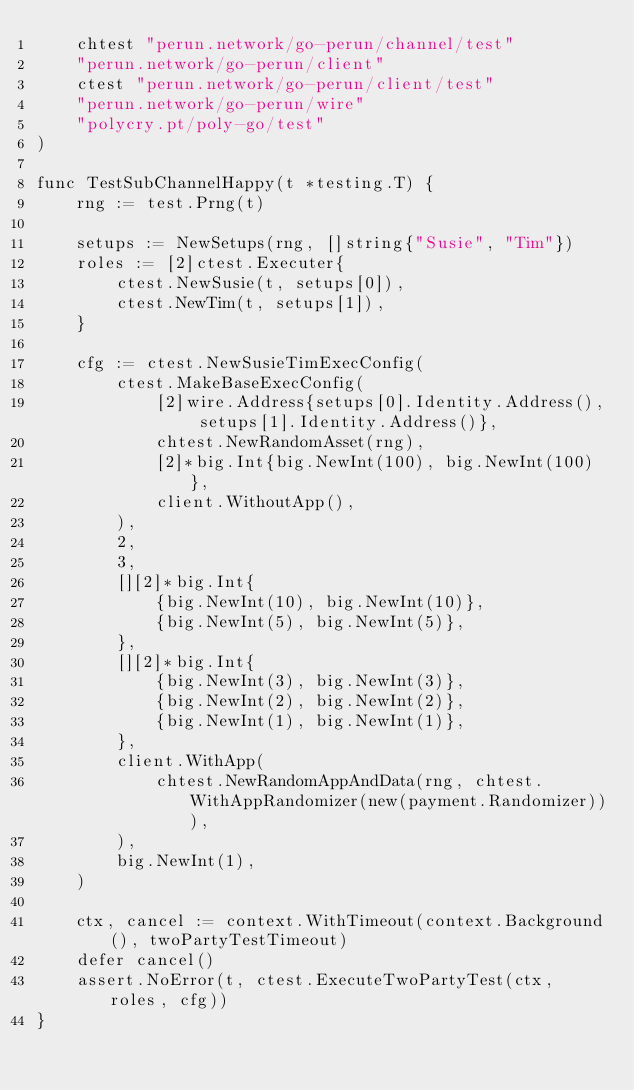<code> <loc_0><loc_0><loc_500><loc_500><_Go_>	chtest "perun.network/go-perun/channel/test"
	"perun.network/go-perun/client"
	ctest "perun.network/go-perun/client/test"
	"perun.network/go-perun/wire"
	"polycry.pt/poly-go/test"
)

func TestSubChannelHappy(t *testing.T) {
	rng := test.Prng(t)

	setups := NewSetups(rng, []string{"Susie", "Tim"})
	roles := [2]ctest.Executer{
		ctest.NewSusie(t, setups[0]),
		ctest.NewTim(t, setups[1]),
	}

	cfg := ctest.NewSusieTimExecConfig(
		ctest.MakeBaseExecConfig(
			[2]wire.Address{setups[0].Identity.Address(), setups[1].Identity.Address()},
			chtest.NewRandomAsset(rng),
			[2]*big.Int{big.NewInt(100), big.NewInt(100)},
			client.WithoutApp(),
		),
		2,
		3,
		[][2]*big.Int{
			{big.NewInt(10), big.NewInt(10)},
			{big.NewInt(5), big.NewInt(5)},
		},
		[][2]*big.Int{
			{big.NewInt(3), big.NewInt(3)},
			{big.NewInt(2), big.NewInt(2)},
			{big.NewInt(1), big.NewInt(1)},
		},
		client.WithApp(
			chtest.NewRandomAppAndData(rng, chtest.WithAppRandomizer(new(payment.Randomizer))),
		),
		big.NewInt(1),
	)

	ctx, cancel := context.WithTimeout(context.Background(), twoPartyTestTimeout)
	defer cancel()
	assert.NoError(t, ctest.ExecuteTwoPartyTest(ctx, roles, cfg))
}
</code> 